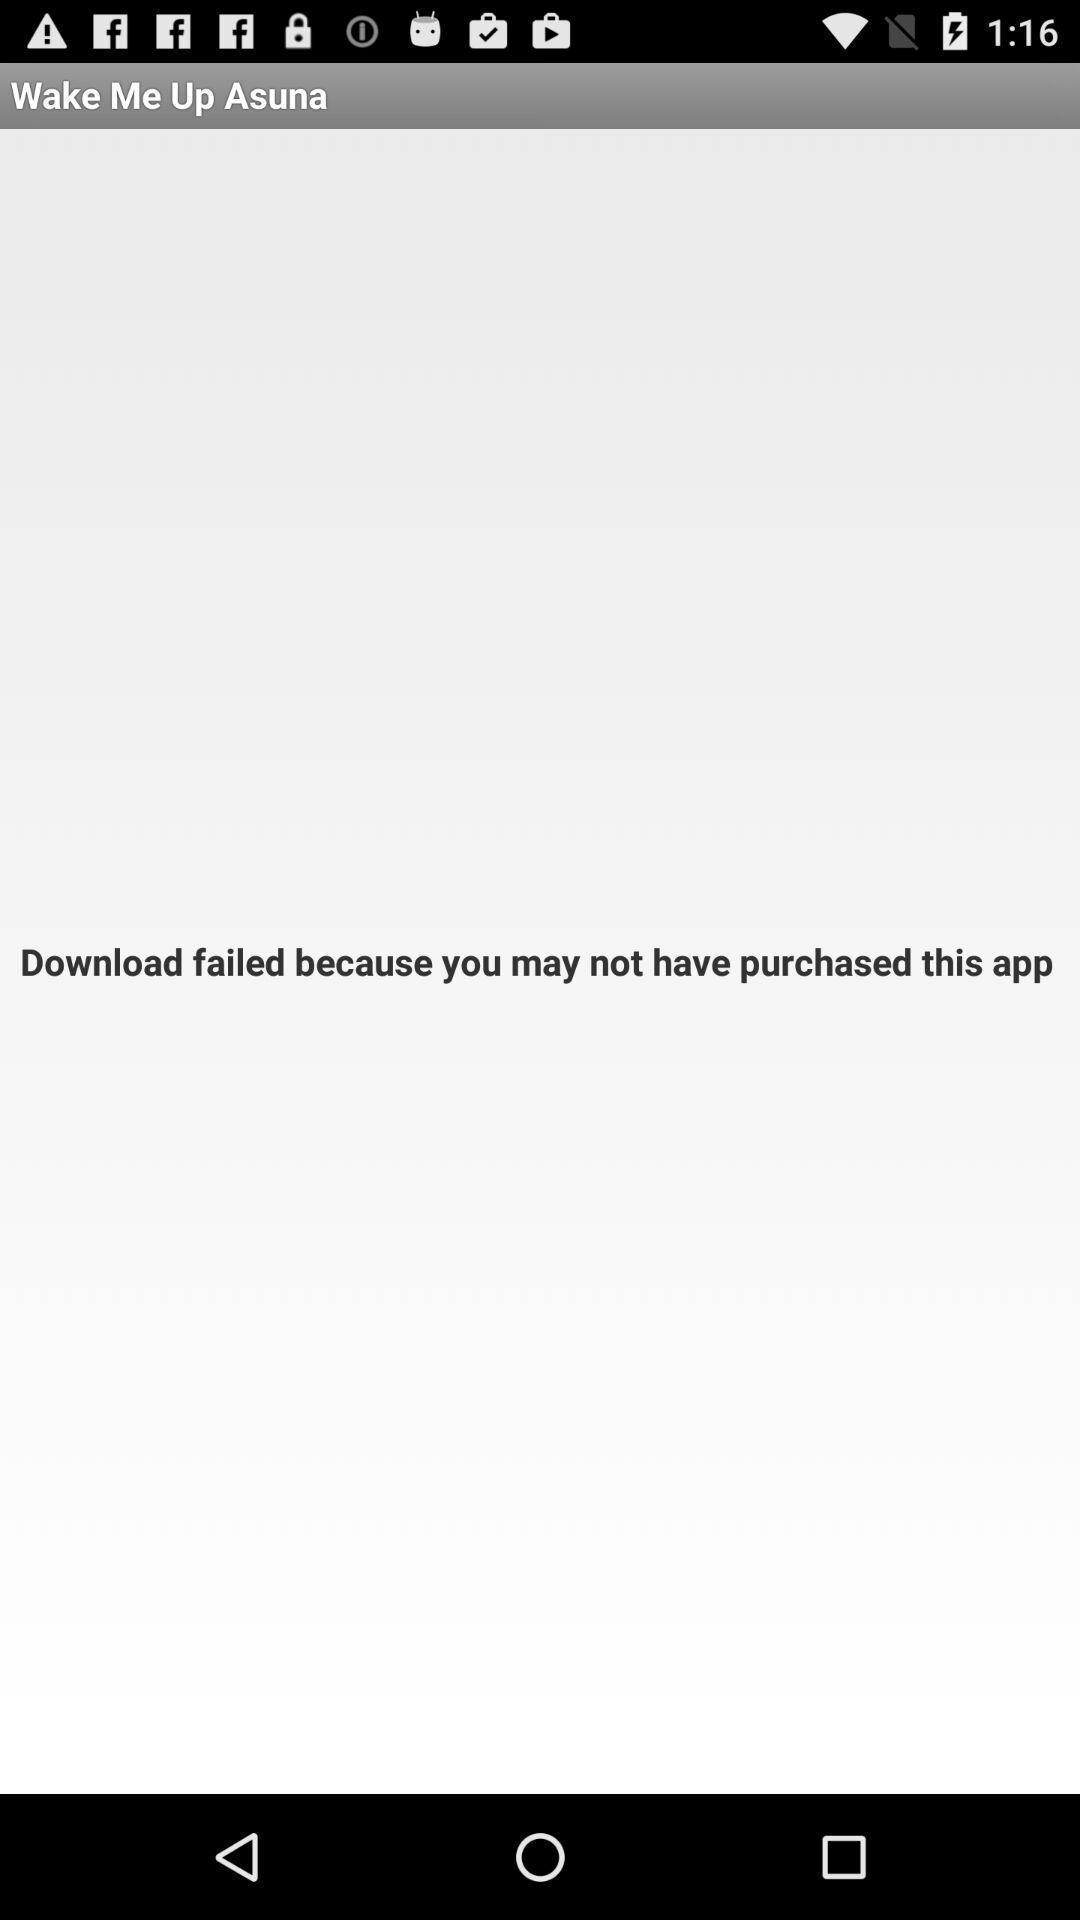What can you discern from this picture? Screen shows the details of a purchase. 